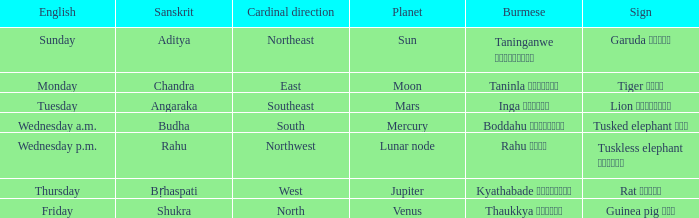What is the planet associated with the direction of south? Mercury. 